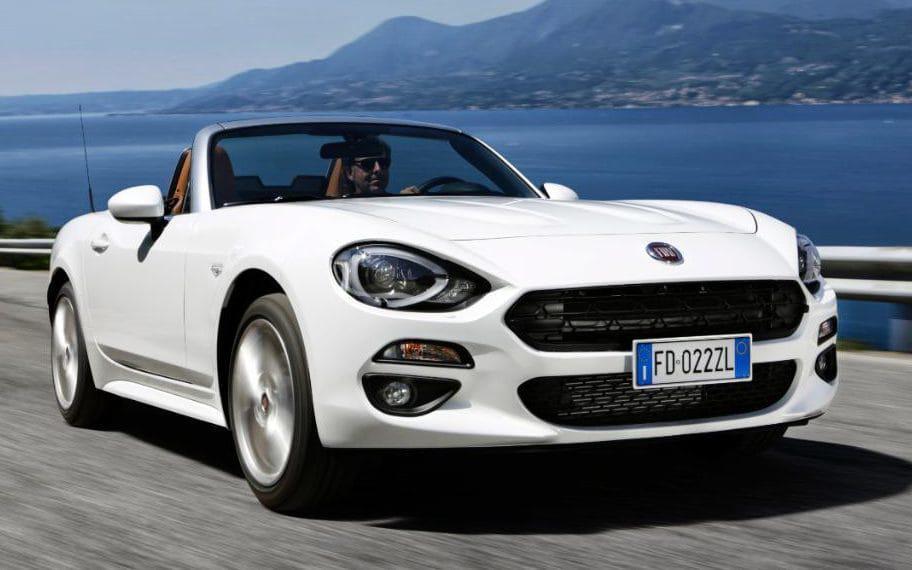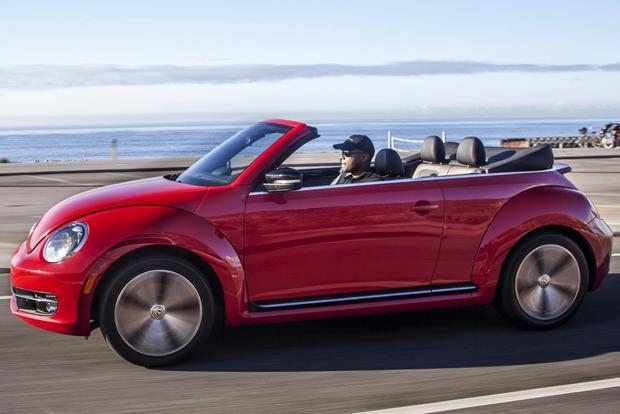The first image is the image on the left, the second image is the image on the right. Analyze the images presented: Is the assertion "a convertible is parked on a sandy lot with grass in the background" valid? Answer yes or no. No. The first image is the image on the left, the second image is the image on the right. Considering the images on both sides, is "One of the convertibles is red." valid? Answer yes or no. Yes. 